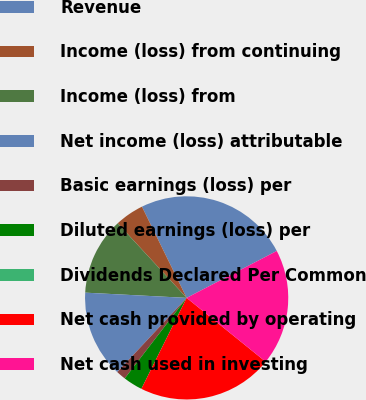Convert chart. <chart><loc_0><loc_0><loc_500><loc_500><pie_chart><fcel>Revenue<fcel>Income (loss) from continuing<fcel>Income (loss) from<fcel>Net income (loss) attributable<fcel>Basic earnings (loss) per<fcel>Diluted earnings (loss) per<fcel>Dividends Declared Per Common<fcel>Net cash provided by operating<fcel>Net cash used in investing<nl><fcel>24.62%<fcel>4.62%<fcel>12.31%<fcel>13.85%<fcel>1.54%<fcel>3.08%<fcel>0.0%<fcel>21.54%<fcel>18.46%<nl></chart> 